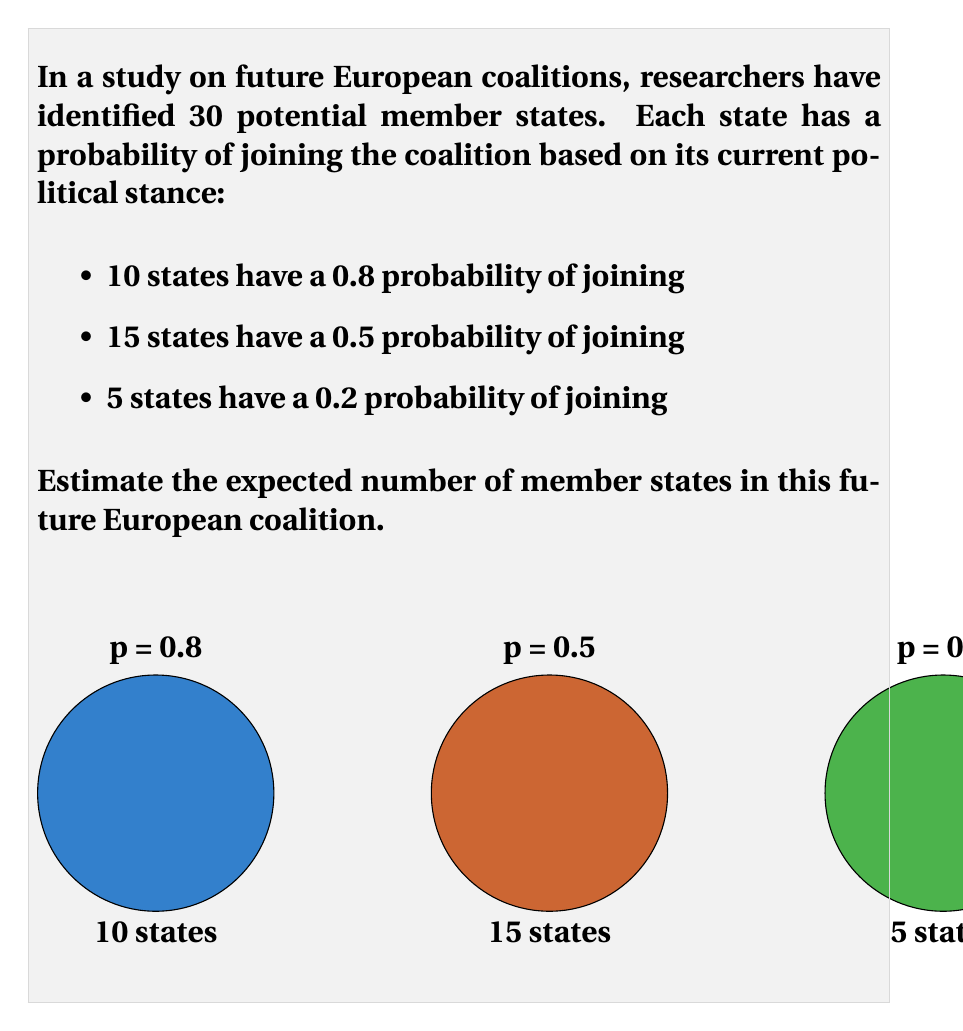Can you solve this math problem? To solve this problem, we need to calculate the expected value of the number of member states. We'll do this step-by-step:

1) The expected value is calculated by multiplying each possible outcome by its probability and then summing these products.

2) For each group of states:

   a) 10 states with p = 0.8:
      Expected number = $10 \times 0.8 = 8$

   b) 15 states with p = 0.5:
      Expected number = $15 \times 0.5 = 7.5$

   c) 5 states with p = 0.2:
      Expected number = $5 \times 0.2 = 1$

3) The total expected number of member states is the sum of these:

   $E(\text{total members}) = 8 + 7.5 + 1 = 16.5$

4) Mathematically, we can express this as:

   $$E(\text{total members}) = \sum_{i=1}^{3} n_i p_i$$

   Where $n_i$ is the number of states in each group and $p_i$ is their respective probability of joining.

5) Substituting the values:

   $$E(\text{total members}) = (10 \times 0.8) + (15 \times 0.5) + (5 \times 0.2) = 16.5$$

Therefore, the expected number of member states in this future European coalition is 16.5.
Answer: 16.5 member states 